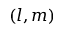<formula> <loc_0><loc_0><loc_500><loc_500>( l , m )</formula> 